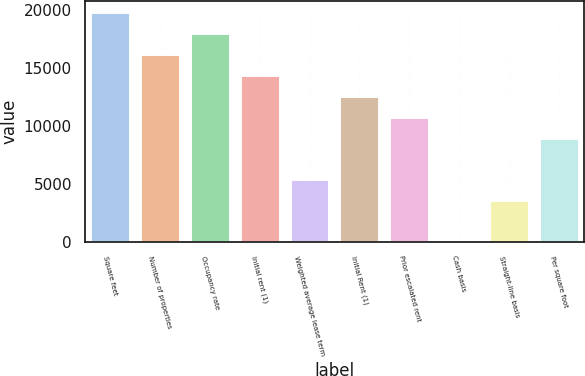Convert chart. <chart><loc_0><loc_0><loc_500><loc_500><bar_chart><fcel>Square feet<fcel>Number of properties<fcel>Occupancy rate<fcel>Initial rent (1)<fcel>Weighted average lease term<fcel>Initial Rent (1)<fcel>Prior escalated rent<fcel>Cash basis<fcel>Straight-line basis<fcel>Per square foot<nl><fcel>19816.3<fcel>16213.7<fcel>18015<fcel>14412.5<fcel>5406.18<fcel>12611.2<fcel>10810<fcel>2.4<fcel>3604.92<fcel>9008.7<nl></chart> 